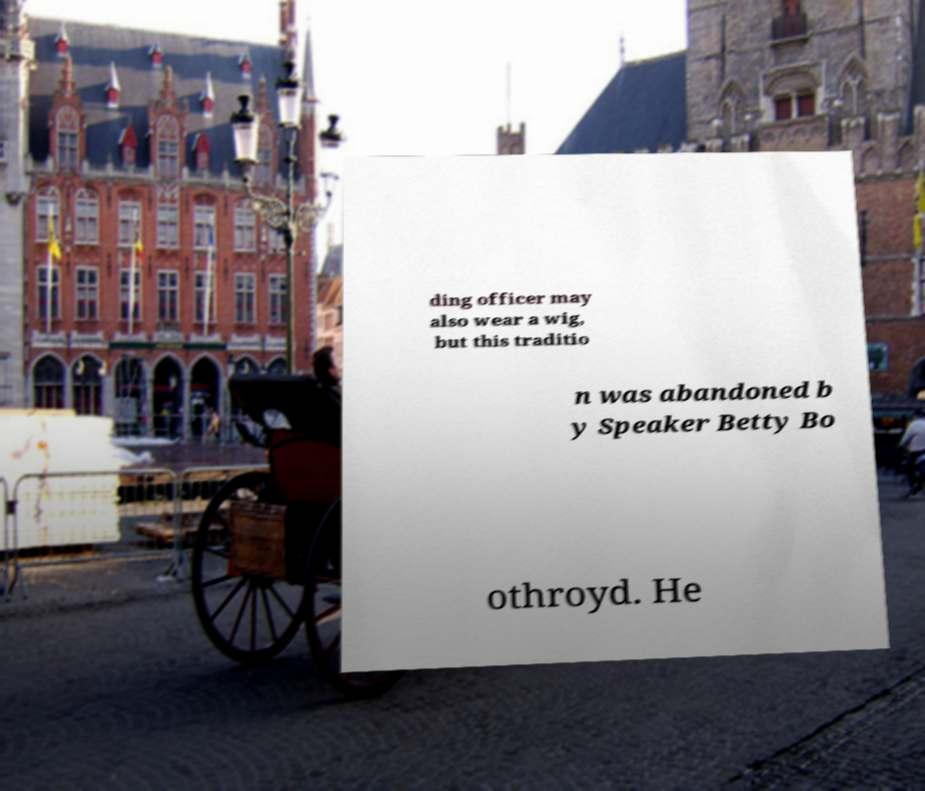There's text embedded in this image that I need extracted. Can you transcribe it verbatim? ding officer may also wear a wig, but this traditio n was abandoned b y Speaker Betty Bo othroyd. He 